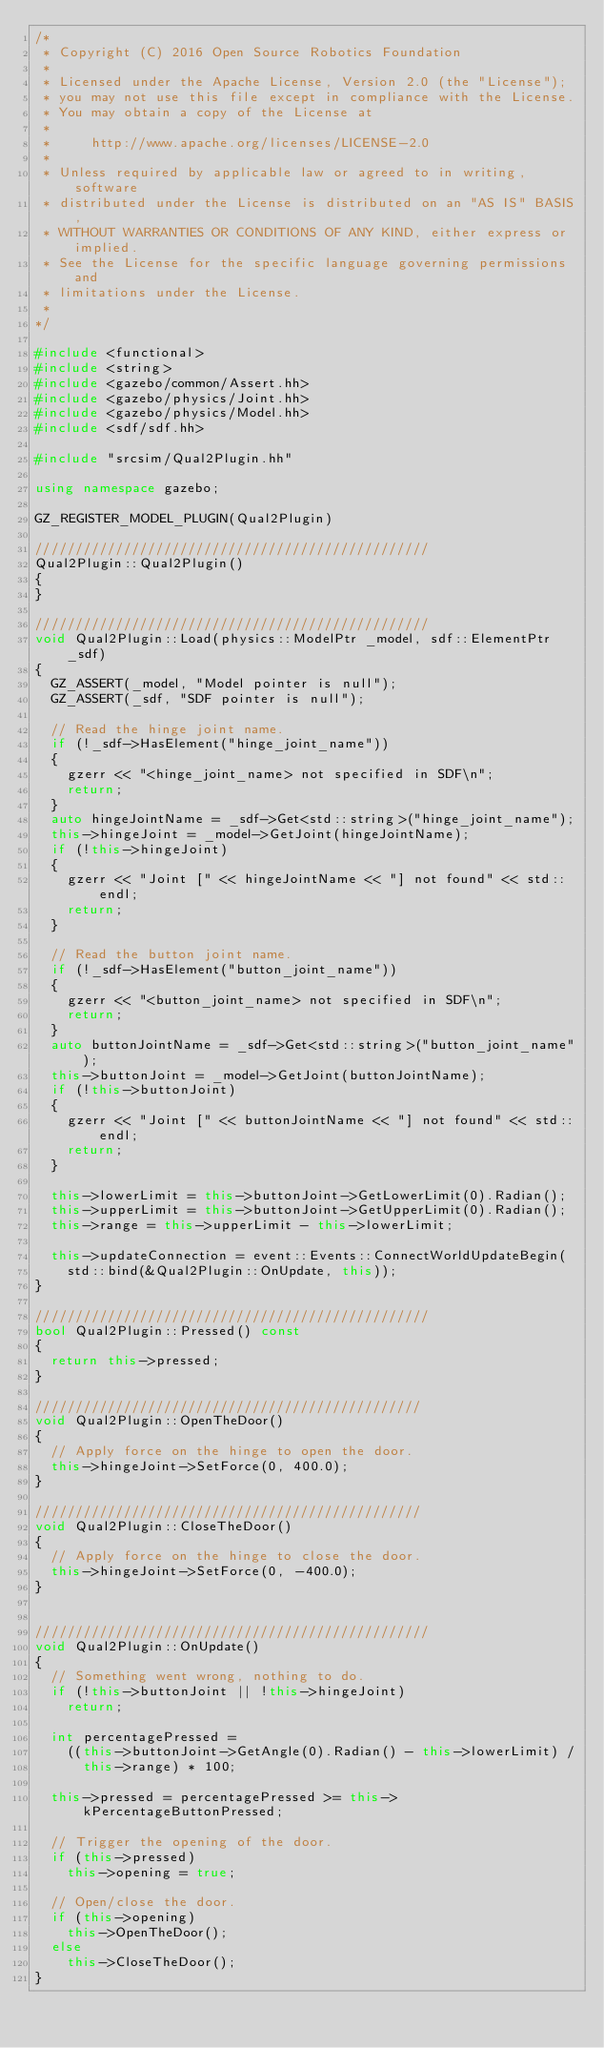<code> <loc_0><loc_0><loc_500><loc_500><_C++_>/*
 * Copyright (C) 2016 Open Source Robotics Foundation
 *
 * Licensed under the Apache License, Version 2.0 (the "License");
 * you may not use this file except in compliance with the License.
 * You may obtain a copy of the License at
 *
 *     http://www.apache.org/licenses/LICENSE-2.0
 *
 * Unless required by applicable law or agreed to in writing, software
 * distributed under the License is distributed on an "AS IS" BASIS,
 * WITHOUT WARRANTIES OR CONDITIONS OF ANY KIND, either express or implied.
 * See the License for the specific language governing permissions and
 * limitations under the License.
 *
*/

#include <functional>
#include <string>
#include <gazebo/common/Assert.hh>
#include <gazebo/physics/Joint.hh>
#include <gazebo/physics/Model.hh>
#include <sdf/sdf.hh>

#include "srcsim/Qual2Plugin.hh"

using namespace gazebo;

GZ_REGISTER_MODEL_PLUGIN(Qual2Plugin)

/////////////////////////////////////////////////
Qual2Plugin::Qual2Plugin()
{
}

/////////////////////////////////////////////////
void Qual2Plugin::Load(physics::ModelPtr _model, sdf::ElementPtr _sdf)
{
  GZ_ASSERT(_model, "Model pointer is null");
  GZ_ASSERT(_sdf, "SDF pointer is null");

  // Read the hinge joint name.
  if (!_sdf->HasElement("hinge_joint_name"))
  {
    gzerr << "<hinge_joint_name> not specified in SDF\n";
    return;
  }
  auto hingeJointName = _sdf->Get<std::string>("hinge_joint_name");
  this->hingeJoint = _model->GetJoint(hingeJointName);
  if (!this->hingeJoint)
  {
    gzerr << "Joint [" << hingeJointName << "] not found" << std::endl;
    return;
  }

  // Read the button joint name.
  if (!_sdf->HasElement("button_joint_name"))
  {
    gzerr << "<button_joint_name> not specified in SDF\n";
    return;
  }
  auto buttonJointName = _sdf->Get<std::string>("button_joint_name");
  this->buttonJoint = _model->GetJoint(buttonJointName);
  if (!this->buttonJoint)
  {
    gzerr << "Joint [" << buttonJointName << "] not found" << std::endl;
    return;
  }

  this->lowerLimit = this->buttonJoint->GetLowerLimit(0).Radian();
  this->upperLimit = this->buttonJoint->GetUpperLimit(0).Radian();
  this->range = this->upperLimit - this->lowerLimit;

  this->updateConnection = event::Events::ConnectWorldUpdateBegin(
    std::bind(&Qual2Plugin::OnUpdate, this));
}

/////////////////////////////////////////////////
bool Qual2Plugin::Pressed() const
{
  return this->pressed;
}

////////////////////////////////////////////////
void Qual2Plugin::OpenTheDoor()
{
  // Apply force on the hinge to open the door.
  this->hingeJoint->SetForce(0, 400.0);
}

////////////////////////////////////////////////
void Qual2Plugin::CloseTheDoor()
{
  // Apply force on the hinge to close the door.
  this->hingeJoint->SetForce(0, -400.0);
}


/////////////////////////////////////////////////
void Qual2Plugin::OnUpdate()
{
  // Something went wrong, nothing to do.
  if (!this->buttonJoint || !this->hingeJoint)
    return;

  int percentagePressed =
    ((this->buttonJoint->GetAngle(0).Radian() - this->lowerLimit) /
      this->range) * 100;

  this->pressed = percentagePressed >= this->kPercentageButtonPressed;

  // Trigger the opening of the door.
  if (this->pressed)
    this->opening = true;

  // Open/close the door.
  if (this->opening)
    this->OpenTheDoor();
  else
    this->CloseTheDoor();
}
</code> 